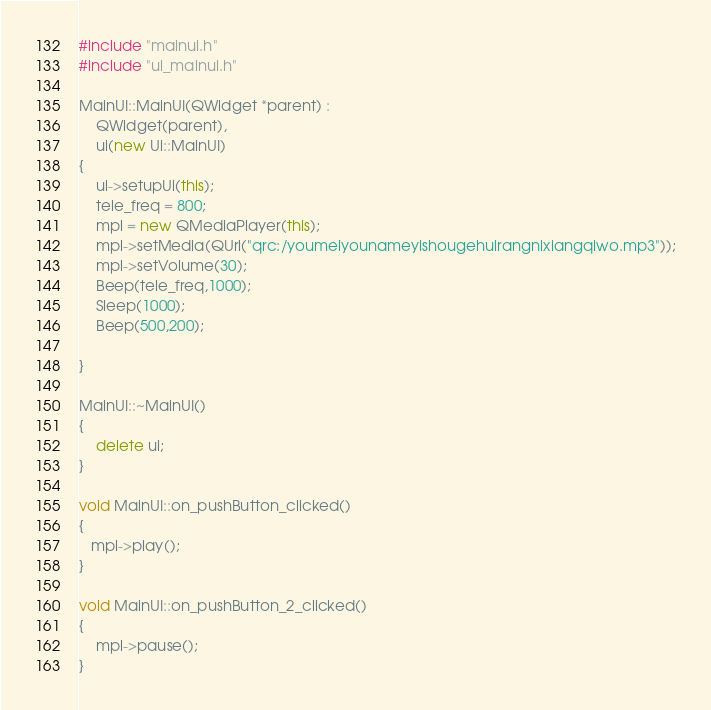<code> <loc_0><loc_0><loc_500><loc_500><_C++_>#include "mainui.h"
#include "ui_mainui.h"

MainUI::MainUI(QWidget *parent) :
    QWidget(parent),
    ui(new Ui::MainUI)
{
    ui->setupUi(this);
    tele_freq = 800;
    mpl = new QMediaPlayer(this);
    mpl->setMedia(QUrl("qrc:/youmeiyounameyishougehuirangnixiangqiwo.mp3"));
    mpl->setVolume(30);
    Beep(tele_freq,1000);
    Sleep(1000);
    Beep(500,200);

}

MainUI::~MainUI()
{
    delete ui;
}

void MainUI::on_pushButton_clicked()
{
   mpl->play();
}

void MainUI::on_pushButton_2_clicked()
{
    mpl->pause();
}
</code> 